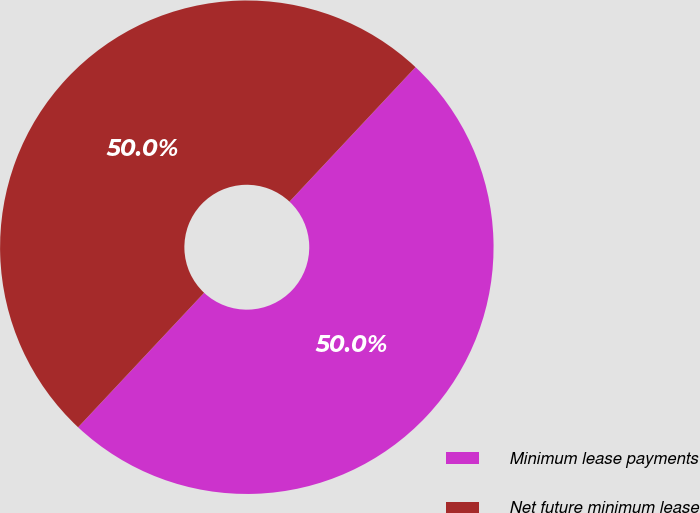<chart> <loc_0><loc_0><loc_500><loc_500><pie_chart><fcel>Minimum lease payments<fcel>Net future minimum lease<nl><fcel>50.0%<fcel>50.0%<nl></chart> 